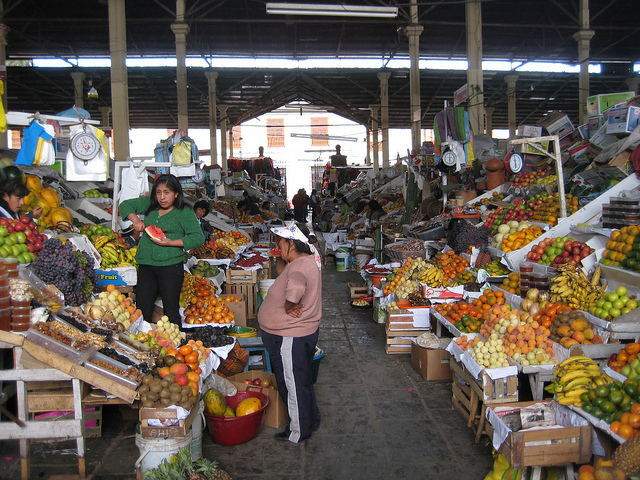How many people are there? 2 